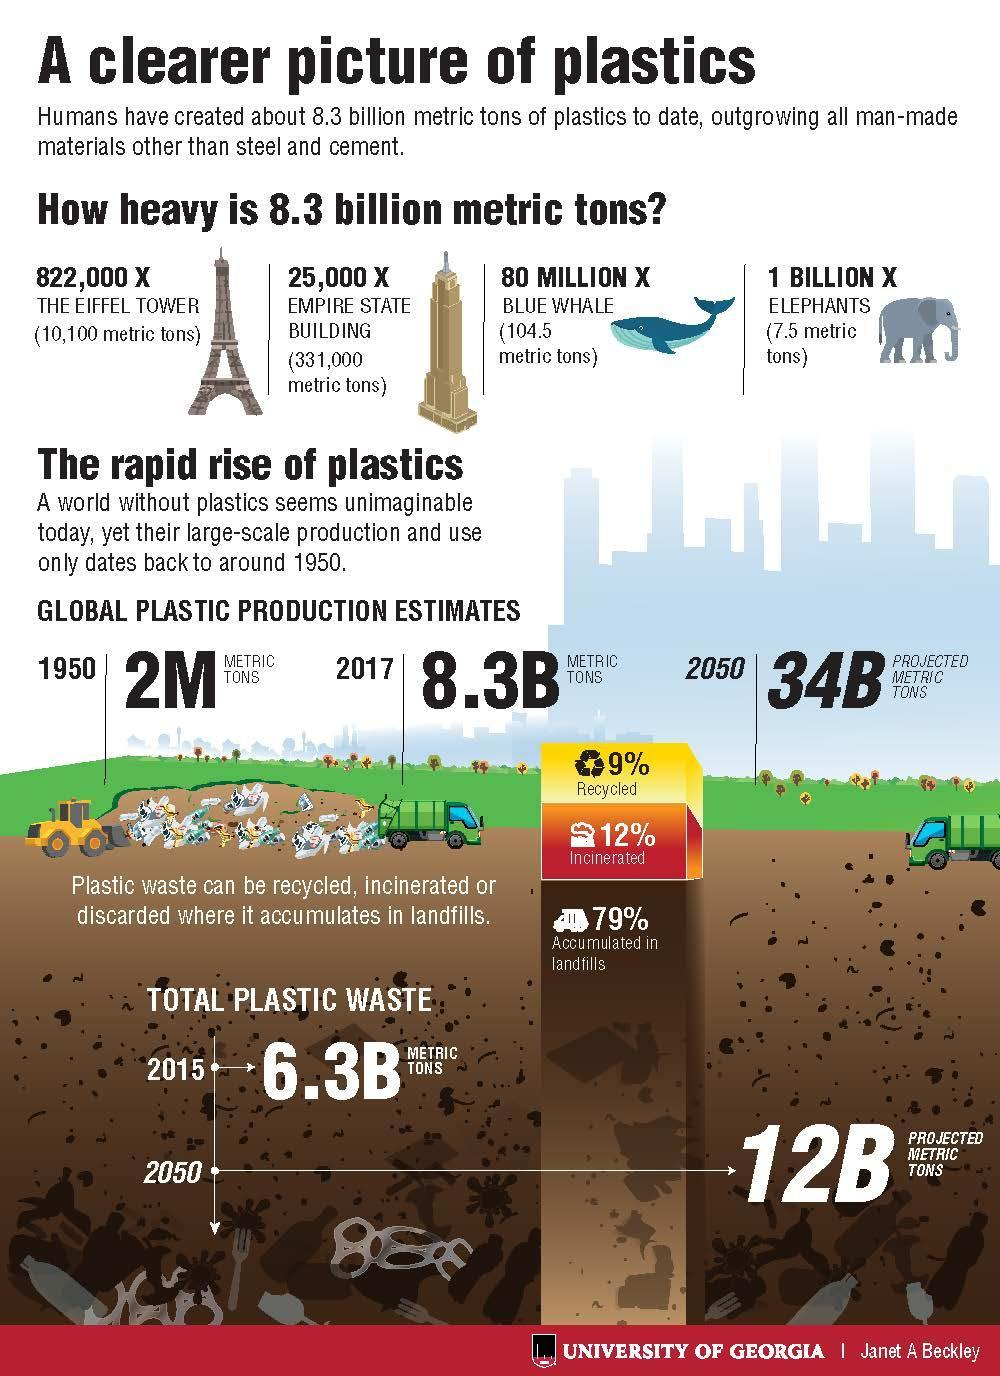Indicate a few pertinent items in this graphic. By 2050, it is projected that global plastic production will reach 34 billion metric tons, representing a significant increase from current levels. In 2017, the estimated global production of plastic was 8.3 billion metric tons. According to the data, only 21% of plastic waste was not accumulated in landfills. According to recent data, approximately 12% of plastic waste is incinerated. 